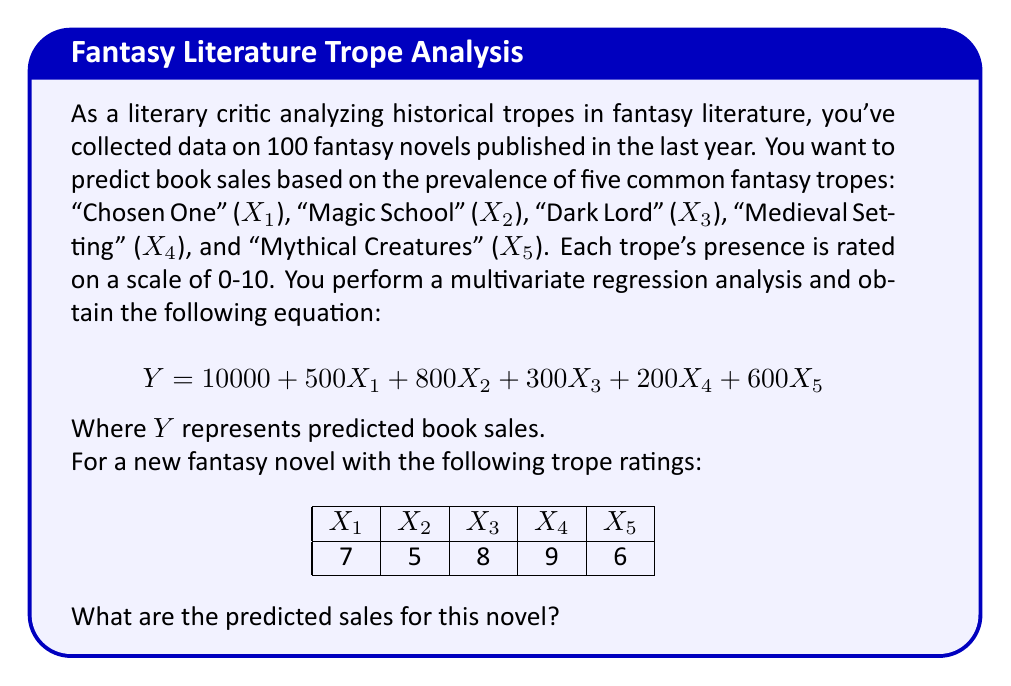Show me your answer to this math problem. To solve this problem, we need to follow these steps:

1. Identify the regression equation:
   $$ Y = 10000 + 500X_1 + 800X_2 + 300X_3 + 200X_4 + 600X_5 $$

2. Substitute the given values for each trope:
   X1 = 7 (Chosen One)
   X2 = 5 (Magic School)
   X3 = 8 (Dark Lord)
   X4 = 9 (Medieval Setting)
   X5 = 6 (Mythical Creatures)

3. Calculate each term in the equation:
   - Constant term: 10000
   - 500X1 = 500 * 7 = 3500
   - 800X2 = 800 * 5 = 4000
   - 300X3 = 300 * 8 = 2400
   - 200X4 = 200 * 9 = 1800
   - 600X5 = 600 * 6 = 3600

4. Sum up all the terms:
   $$ Y = 10000 + 3500 + 4000 + 2400 + 1800 + 3600 $$

5. Calculate the final result:
   $$ Y = 25300 $$

Therefore, the predicted sales for this novel are 25,300 copies.
Answer: 25,300 copies 